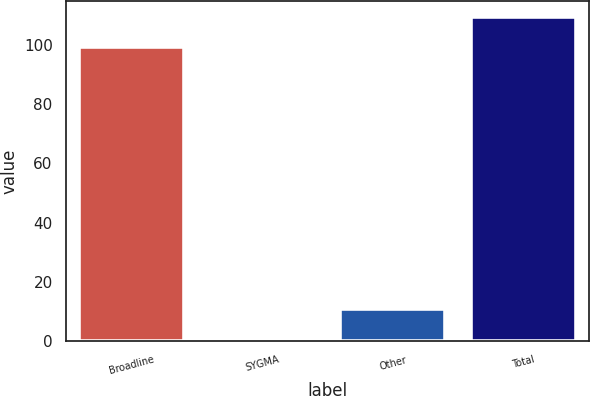<chart> <loc_0><loc_0><loc_500><loc_500><bar_chart><fcel>Broadline<fcel>SYGMA<fcel>Other<fcel>Total<nl><fcel>99.4<fcel>1.2<fcel>11.08<fcel>109.28<nl></chart> 